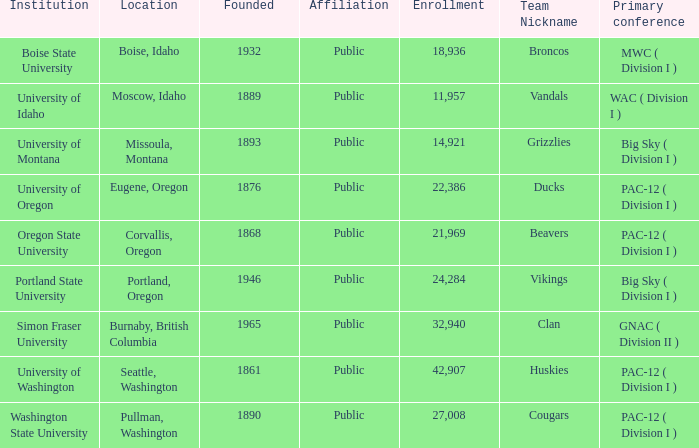What is the location of the University of Montana, which was founded after 1890? Missoula, Montana. 